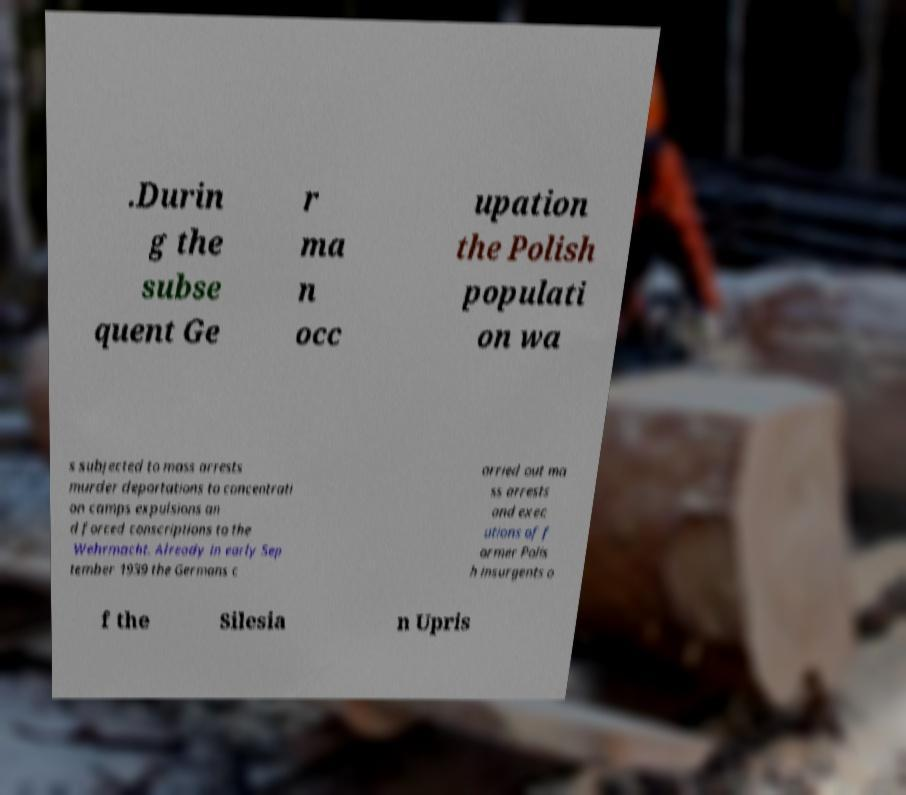Please identify and transcribe the text found in this image. .Durin g the subse quent Ge r ma n occ upation the Polish populati on wa s subjected to mass arrests murder deportations to concentrati on camps expulsions an d forced conscriptions to the Wehrmacht. Already in early Sep tember 1939 the Germans c arried out ma ss arrests and exec utions of f ormer Polis h insurgents o f the Silesia n Upris 